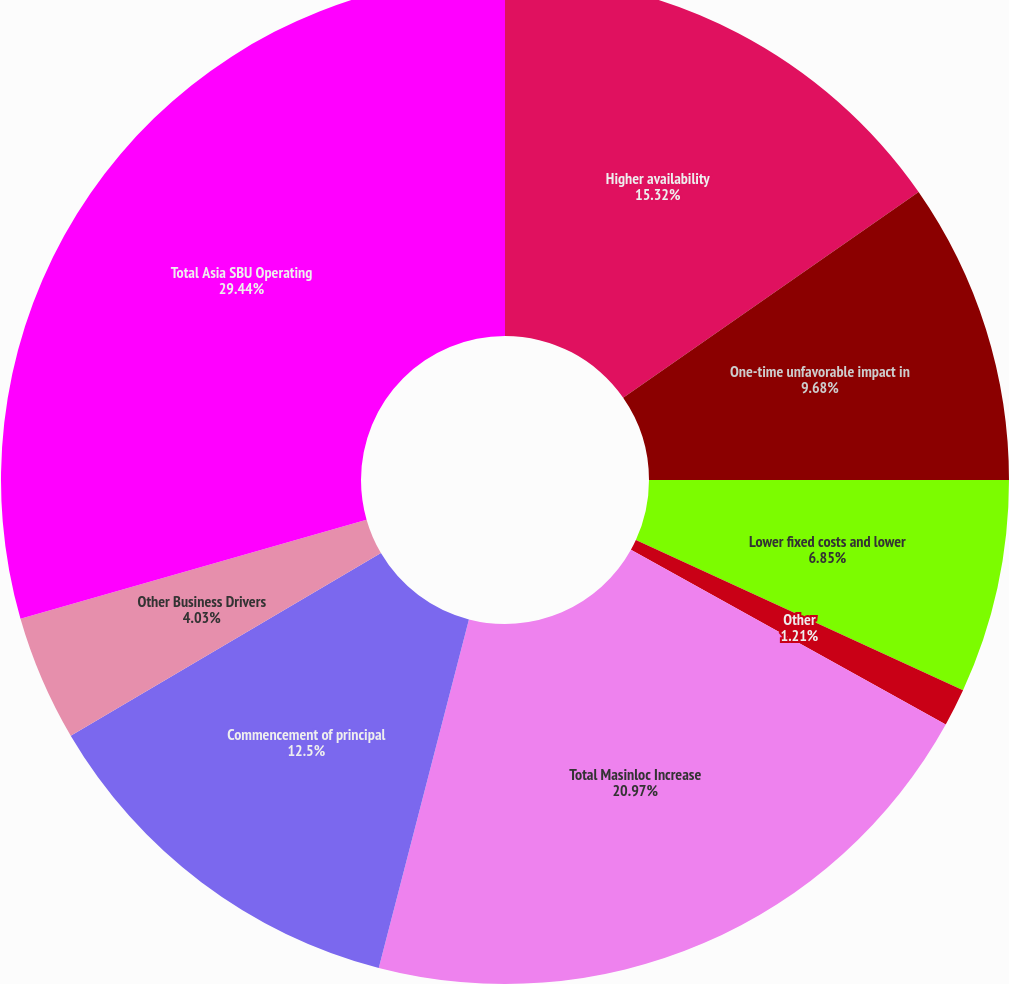<chart> <loc_0><loc_0><loc_500><loc_500><pie_chart><fcel>Higher availability<fcel>One-time unfavorable impact in<fcel>Lower fixed costs and lower<fcel>Other<fcel>Total Masinloc Increase<fcel>Commencement of principal<fcel>Other Business Drivers<fcel>Total Asia SBU Operating<nl><fcel>15.32%<fcel>9.68%<fcel>6.85%<fcel>1.21%<fcel>20.97%<fcel>12.5%<fcel>4.03%<fcel>29.44%<nl></chart> 